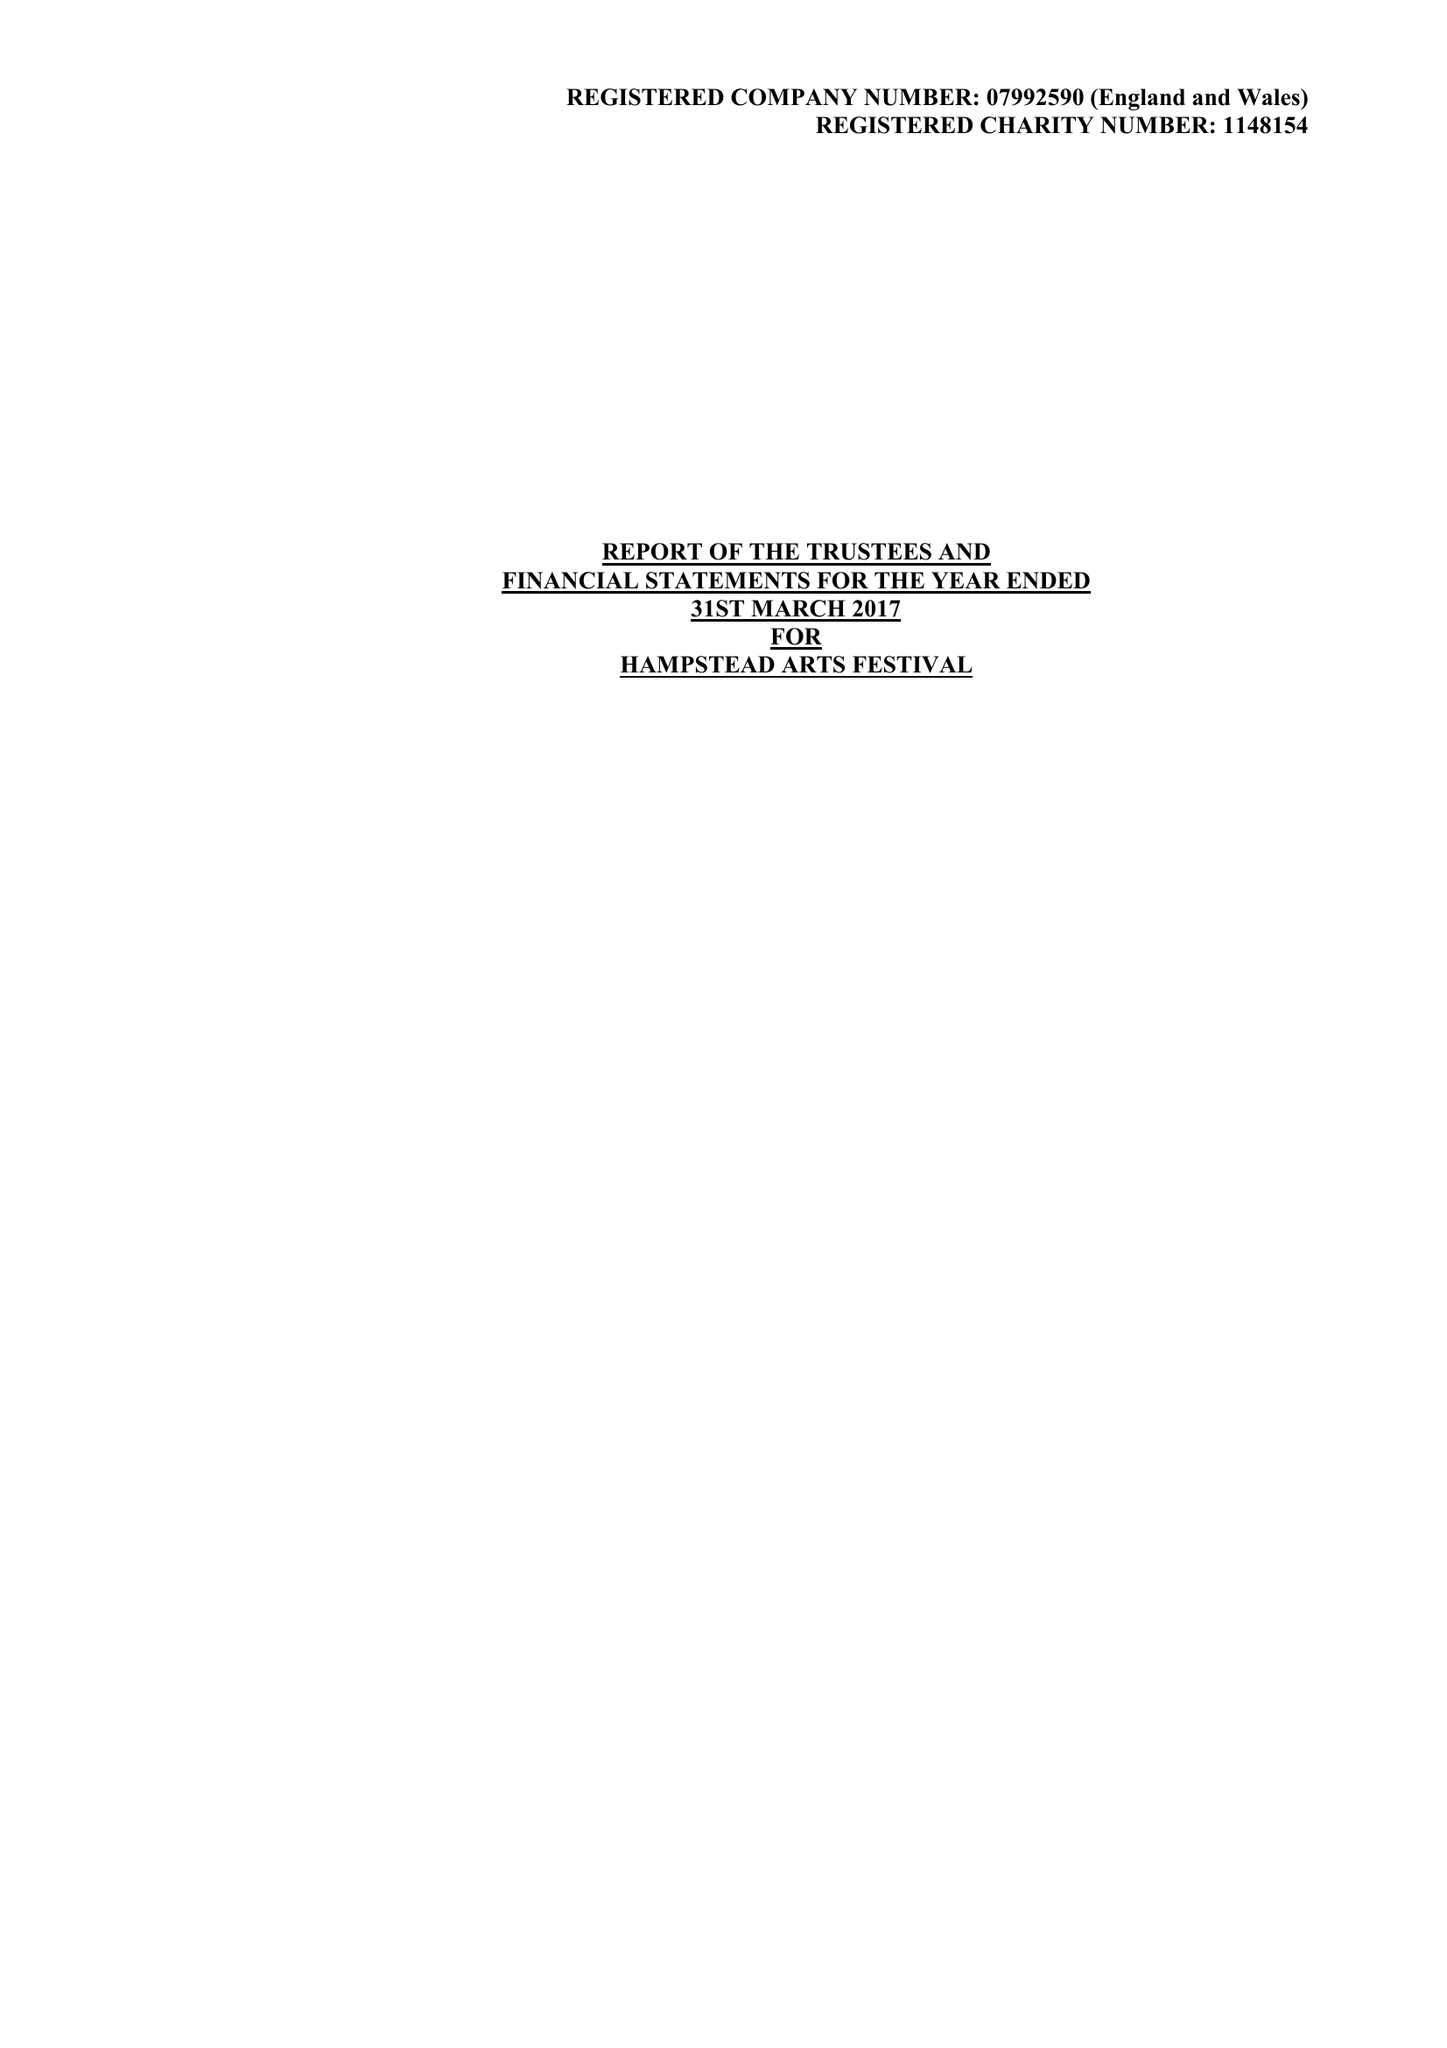What is the value for the address__post_town?
Answer the question using a single word or phrase. HARROW 